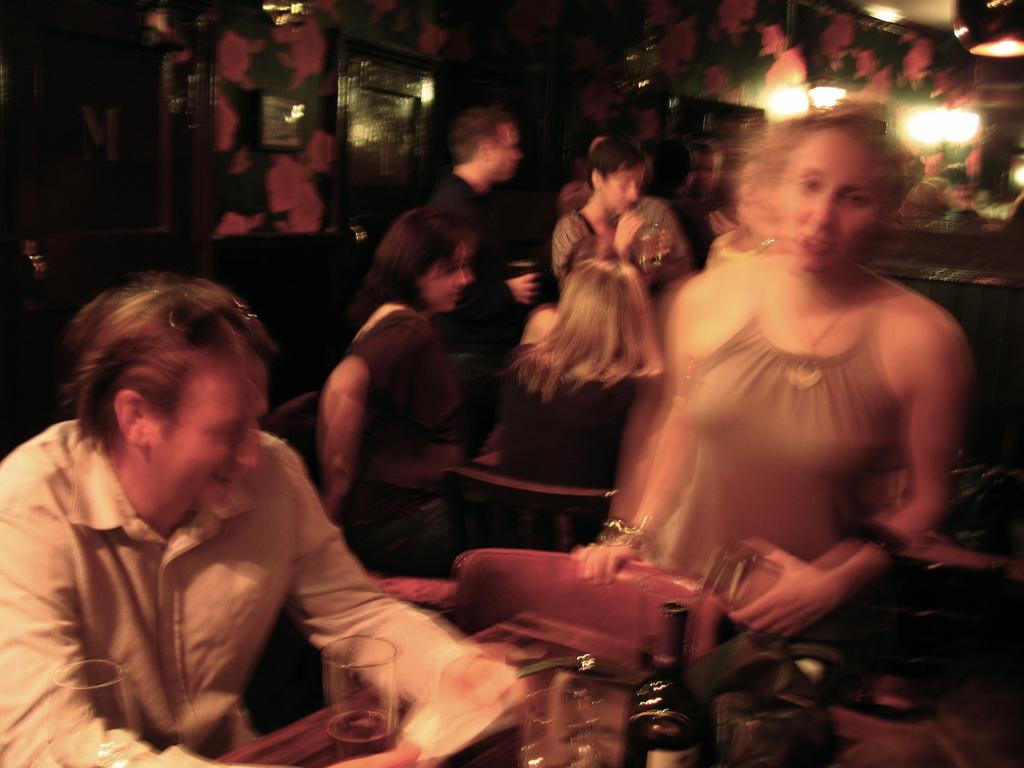What are the persons in the image doing? The persons in the image are sitting on chairs and having drinks. How are the persons arranged in the image? The persons are sitting around tables. What can be seen in the background of the image? There is a wall, lights, and doors in the background of the image. What type of texture can be seen on the yam in the image? There is no yam present in the image, so it is not possible to determine its texture. 